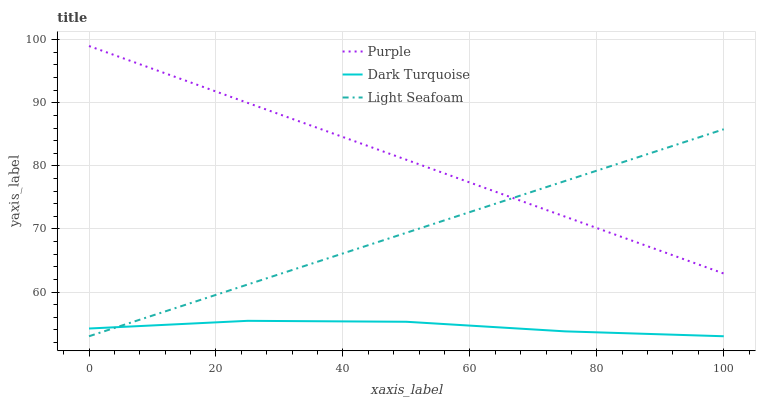Does Light Seafoam have the minimum area under the curve?
Answer yes or no. No. Does Light Seafoam have the maximum area under the curve?
Answer yes or no. No. Is Light Seafoam the smoothest?
Answer yes or no. No. Is Light Seafoam the roughest?
Answer yes or no. No. Does Light Seafoam have the highest value?
Answer yes or no. No. Is Dark Turquoise less than Purple?
Answer yes or no. Yes. Is Purple greater than Dark Turquoise?
Answer yes or no. Yes. Does Dark Turquoise intersect Purple?
Answer yes or no. No. 